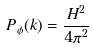<formula> <loc_0><loc_0><loc_500><loc_500>P _ { \phi } ( k ) = \frac { H ^ { 2 } } { 4 \pi ^ { 2 } }</formula> 